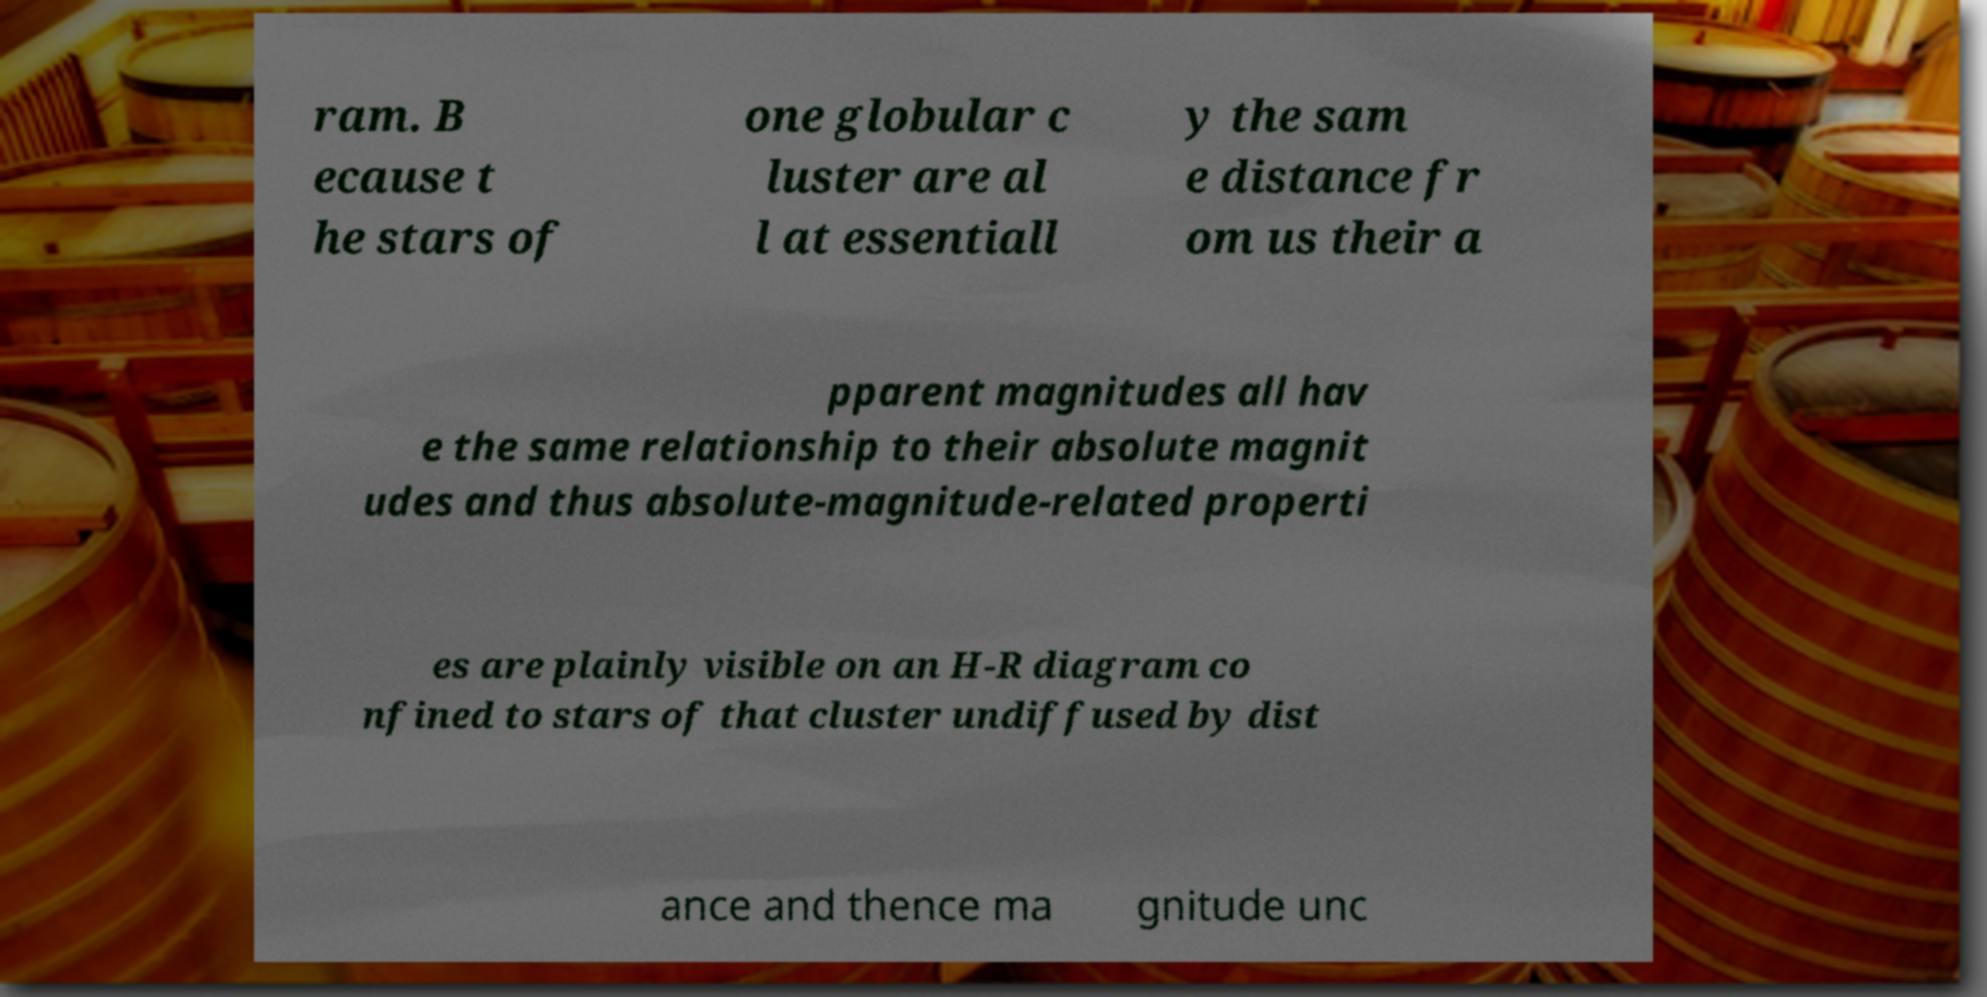Could you assist in decoding the text presented in this image and type it out clearly? ram. B ecause t he stars of one globular c luster are al l at essentiall y the sam e distance fr om us their a pparent magnitudes all hav e the same relationship to their absolute magnit udes and thus absolute-magnitude-related properti es are plainly visible on an H-R diagram co nfined to stars of that cluster undiffused by dist ance and thence ma gnitude unc 